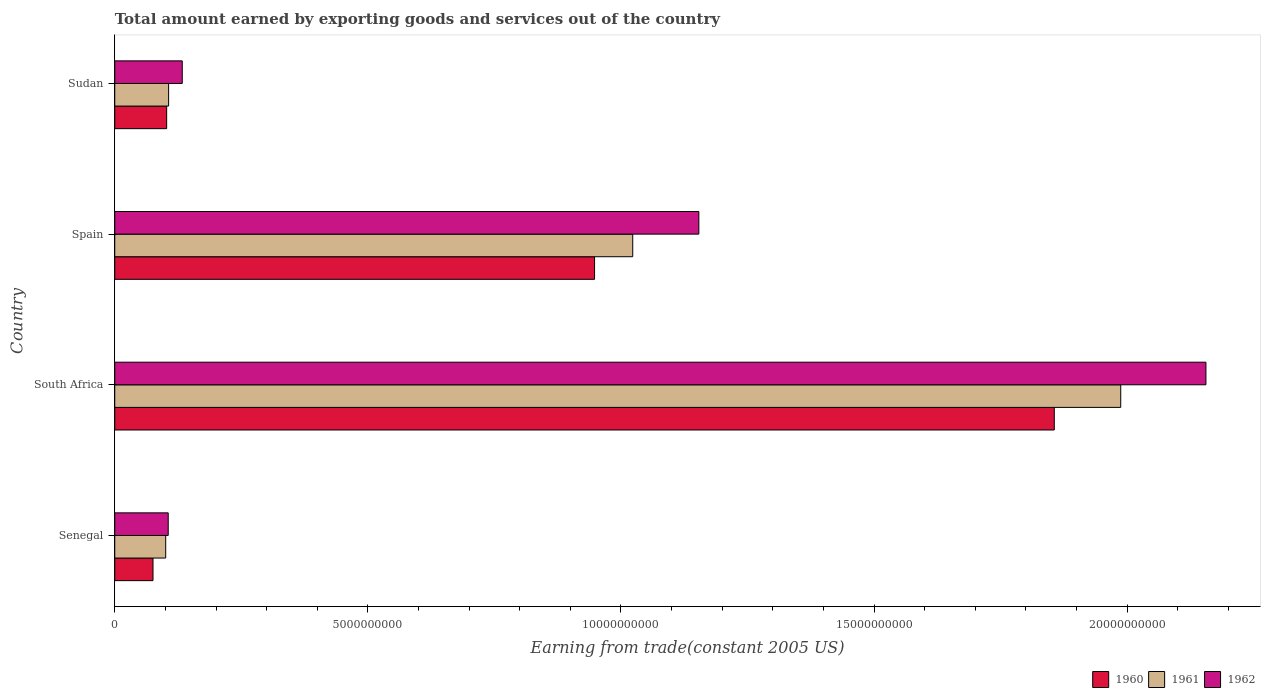How many different coloured bars are there?
Make the answer very short. 3. Are the number of bars on each tick of the Y-axis equal?
Your response must be concise. Yes. What is the label of the 2nd group of bars from the top?
Your answer should be very brief. Spain. In how many cases, is the number of bars for a given country not equal to the number of legend labels?
Offer a terse response. 0. What is the total amount earned by exporting goods and services in 1961 in Spain?
Give a very brief answer. 1.02e+1. Across all countries, what is the maximum total amount earned by exporting goods and services in 1961?
Your response must be concise. 1.99e+1. Across all countries, what is the minimum total amount earned by exporting goods and services in 1961?
Ensure brevity in your answer.  1.01e+09. In which country was the total amount earned by exporting goods and services in 1960 maximum?
Provide a succinct answer. South Africa. In which country was the total amount earned by exporting goods and services in 1961 minimum?
Provide a short and direct response. Senegal. What is the total total amount earned by exporting goods and services in 1960 in the graph?
Your response must be concise. 2.98e+1. What is the difference between the total amount earned by exporting goods and services in 1961 in South Africa and that in Sudan?
Your answer should be compact. 1.88e+1. What is the difference between the total amount earned by exporting goods and services in 1960 in Spain and the total amount earned by exporting goods and services in 1962 in South Africa?
Give a very brief answer. -1.21e+1. What is the average total amount earned by exporting goods and services in 1960 per country?
Provide a short and direct response. 7.45e+09. What is the difference between the total amount earned by exporting goods and services in 1960 and total amount earned by exporting goods and services in 1961 in Sudan?
Your response must be concise. -3.85e+07. In how many countries, is the total amount earned by exporting goods and services in 1960 greater than 14000000000 US$?
Keep it short and to the point. 1. What is the ratio of the total amount earned by exporting goods and services in 1961 in Spain to that in Sudan?
Your answer should be compact. 9.62. Is the total amount earned by exporting goods and services in 1961 in Spain less than that in Sudan?
Provide a succinct answer. No. What is the difference between the highest and the second highest total amount earned by exporting goods and services in 1962?
Provide a succinct answer. 1.00e+1. What is the difference between the highest and the lowest total amount earned by exporting goods and services in 1962?
Ensure brevity in your answer.  2.05e+1. Is the sum of the total amount earned by exporting goods and services in 1961 in South Africa and Spain greater than the maximum total amount earned by exporting goods and services in 1962 across all countries?
Ensure brevity in your answer.  Yes. How many bars are there?
Keep it short and to the point. 12. What is the difference between two consecutive major ticks on the X-axis?
Offer a very short reply. 5.00e+09. Where does the legend appear in the graph?
Your answer should be compact. Bottom right. How are the legend labels stacked?
Give a very brief answer. Horizontal. What is the title of the graph?
Offer a terse response. Total amount earned by exporting goods and services out of the country. What is the label or title of the X-axis?
Make the answer very short. Earning from trade(constant 2005 US). What is the label or title of the Y-axis?
Provide a short and direct response. Country. What is the Earning from trade(constant 2005 US) of 1960 in Senegal?
Offer a very short reply. 7.56e+08. What is the Earning from trade(constant 2005 US) in 1961 in Senegal?
Offer a terse response. 1.01e+09. What is the Earning from trade(constant 2005 US) in 1962 in Senegal?
Make the answer very short. 1.06e+09. What is the Earning from trade(constant 2005 US) in 1960 in South Africa?
Provide a succinct answer. 1.86e+1. What is the Earning from trade(constant 2005 US) of 1961 in South Africa?
Keep it short and to the point. 1.99e+1. What is the Earning from trade(constant 2005 US) of 1962 in South Africa?
Provide a succinct answer. 2.16e+1. What is the Earning from trade(constant 2005 US) in 1960 in Spain?
Offer a very short reply. 9.48e+09. What is the Earning from trade(constant 2005 US) in 1961 in Spain?
Provide a succinct answer. 1.02e+1. What is the Earning from trade(constant 2005 US) in 1962 in Spain?
Ensure brevity in your answer.  1.15e+1. What is the Earning from trade(constant 2005 US) in 1960 in Sudan?
Provide a short and direct response. 1.03e+09. What is the Earning from trade(constant 2005 US) of 1961 in Sudan?
Provide a short and direct response. 1.06e+09. What is the Earning from trade(constant 2005 US) in 1962 in Sudan?
Ensure brevity in your answer.  1.33e+09. Across all countries, what is the maximum Earning from trade(constant 2005 US) of 1960?
Your answer should be very brief. 1.86e+1. Across all countries, what is the maximum Earning from trade(constant 2005 US) in 1961?
Your answer should be compact. 1.99e+1. Across all countries, what is the maximum Earning from trade(constant 2005 US) of 1962?
Give a very brief answer. 2.16e+1. Across all countries, what is the minimum Earning from trade(constant 2005 US) in 1960?
Your answer should be very brief. 7.56e+08. Across all countries, what is the minimum Earning from trade(constant 2005 US) in 1961?
Your response must be concise. 1.01e+09. Across all countries, what is the minimum Earning from trade(constant 2005 US) of 1962?
Provide a short and direct response. 1.06e+09. What is the total Earning from trade(constant 2005 US) in 1960 in the graph?
Offer a very short reply. 2.98e+1. What is the total Earning from trade(constant 2005 US) of 1961 in the graph?
Make the answer very short. 3.22e+1. What is the total Earning from trade(constant 2005 US) of 1962 in the graph?
Your answer should be very brief. 3.55e+1. What is the difference between the Earning from trade(constant 2005 US) of 1960 in Senegal and that in South Africa?
Your answer should be very brief. -1.78e+1. What is the difference between the Earning from trade(constant 2005 US) of 1961 in Senegal and that in South Africa?
Give a very brief answer. -1.89e+1. What is the difference between the Earning from trade(constant 2005 US) in 1962 in Senegal and that in South Africa?
Make the answer very short. -2.05e+1. What is the difference between the Earning from trade(constant 2005 US) in 1960 in Senegal and that in Spain?
Your response must be concise. -8.72e+09. What is the difference between the Earning from trade(constant 2005 US) in 1961 in Senegal and that in Spain?
Your answer should be very brief. -9.23e+09. What is the difference between the Earning from trade(constant 2005 US) in 1962 in Senegal and that in Spain?
Give a very brief answer. -1.05e+1. What is the difference between the Earning from trade(constant 2005 US) of 1960 in Senegal and that in Sudan?
Your response must be concise. -2.70e+08. What is the difference between the Earning from trade(constant 2005 US) of 1961 in Senegal and that in Sudan?
Ensure brevity in your answer.  -5.74e+07. What is the difference between the Earning from trade(constant 2005 US) of 1962 in Senegal and that in Sudan?
Your answer should be compact. -2.77e+08. What is the difference between the Earning from trade(constant 2005 US) in 1960 in South Africa and that in Spain?
Offer a terse response. 9.08e+09. What is the difference between the Earning from trade(constant 2005 US) in 1961 in South Africa and that in Spain?
Make the answer very short. 9.64e+09. What is the difference between the Earning from trade(constant 2005 US) in 1962 in South Africa and that in Spain?
Your answer should be very brief. 1.00e+1. What is the difference between the Earning from trade(constant 2005 US) in 1960 in South Africa and that in Sudan?
Provide a short and direct response. 1.75e+1. What is the difference between the Earning from trade(constant 2005 US) of 1961 in South Africa and that in Sudan?
Your answer should be very brief. 1.88e+1. What is the difference between the Earning from trade(constant 2005 US) of 1962 in South Africa and that in Sudan?
Provide a succinct answer. 2.02e+1. What is the difference between the Earning from trade(constant 2005 US) of 1960 in Spain and that in Sudan?
Give a very brief answer. 8.45e+09. What is the difference between the Earning from trade(constant 2005 US) of 1961 in Spain and that in Sudan?
Ensure brevity in your answer.  9.17e+09. What is the difference between the Earning from trade(constant 2005 US) in 1962 in Spain and that in Sudan?
Offer a very short reply. 1.02e+1. What is the difference between the Earning from trade(constant 2005 US) of 1960 in Senegal and the Earning from trade(constant 2005 US) of 1961 in South Africa?
Give a very brief answer. -1.91e+1. What is the difference between the Earning from trade(constant 2005 US) in 1960 in Senegal and the Earning from trade(constant 2005 US) in 1962 in South Africa?
Give a very brief answer. -2.08e+1. What is the difference between the Earning from trade(constant 2005 US) of 1961 in Senegal and the Earning from trade(constant 2005 US) of 1962 in South Africa?
Keep it short and to the point. -2.05e+1. What is the difference between the Earning from trade(constant 2005 US) in 1960 in Senegal and the Earning from trade(constant 2005 US) in 1961 in Spain?
Your answer should be very brief. -9.48e+09. What is the difference between the Earning from trade(constant 2005 US) of 1960 in Senegal and the Earning from trade(constant 2005 US) of 1962 in Spain?
Keep it short and to the point. -1.08e+1. What is the difference between the Earning from trade(constant 2005 US) of 1961 in Senegal and the Earning from trade(constant 2005 US) of 1962 in Spain?
Your response must be concise. -1.05e+1. What is the difference between the Earning from trade(constant 2005 US) in 1960 in Senegal and the Earning from trade(constant 2005 US) in 1961 in Sudan?
Your answer should be very brief. -3.08e+08. What is the difference between the Earning from trade(constant 2005 US) in 1960 in Senegal and the Earning from trade(constant 2005 US) in 1962 in Sudan?
Provide a succinct answer. -5.78e+08. What is the difference between the Earning from trade(constant 2005 US) of 1961 in Senegal and the Earning from trade(constant 2005 US) of 1962 in Sudan?
Offer a terse response. -3.27e+08. What is the difference between the Earning from trade(constant 2005 US) of 1960 in South Africa and the Earning from trade(constant 2005 US) of 1961 in Spain?
Offer a very short reply. 8.33e+09. What is the difference between the Earning from trade(constant 2005 US) of 1960 in South Africa and the Earning from trade(constant 2005 US) of 1962 in Spain?
Your answer should be very brief. 7.02e+09. What is the difference between the Earning from trade(constant 2005 US) of 1961 in South Africa and the Earning from trade(constant 2005 US) of 1962 in Spain?
Offer a terse response. 8.33e+09. What is the difference between the Earning from trade(constant 2005 US) in 1960 in South Africa and the Earning from trade(constant 2005 US) in 1961 in Sudan?
Keep it short and to the point. 1.75e+1. What is the difference between the Earning from trade(constant 2005 US) in 1960 in South Africa and the Earning from trade(constant 2005 US) in 1962 in Sudan?
Make the answer very short. 1.72e+1. What is the difference between the Earning from trade(constant 2005 US) of 1961 in South Africa and the Earning from trade(constant 2005 US) of 1962 in Sudan?
Give a very brief answer. 1.85e+1. What is the difference between the Earning from trade(constant 2005 US) in 1960 in Spain and the Earning from trade(constant 2005 US) in 1961 in Sudan?
Your response must be concise. 8.41e+09. What is the difference between the Earning from trade(constant 2005 US) of 1960 in Spain and the Earning from trade(constant 2005 US) of 1962 in Sudan?
Your response must be concise. 8.14e+09. What is the difference between the Earning from trade(constant 2005 US) of 1961 in Spain and the Earning from trade(constant 2005 US) of 1962 in Sudan?
Ensure brevity in your answer.  8.90e+09. What is the average Earning from trade(constant 2005 US) in 1960 per country?
Provide a short and direct response. 7.45e+09. What is the average Earning from trade(constant 2005 US) in 1961 per country?
Ensure brevity in your answer.  8.04e+09. What is the average Earning from trade(constant 2005 US) in 1962 per country?
Ensure brevity in your answer.  8.87e+09. What is the difference between the Earning from trade(constant 2005 US) of 1960 and Earning from trade(constant 2005 US) of 1961 in Senegal?
Offer a terse response. -2.51e+08. What is the difference between the Earning from trade(constant 2005 US) in 1960 and Earning from trade(constant 2005 US) in 1962 in Senegal?
Give a very brief answer. -3.00e+08. What is the difference between the Earning from trade(constant 2005 US) in 1961 and Earning from trade(constant 2005 US) in 1962 in Senegal?
Keep it short and to the point. -4.96e+07. What is the difference between the Earning from trade(constant 2005 US) of 1960 and Earning from trade(constant 2005 US) of 1961 in South Africa?
Offer a terse response. -1.31e+09. What is the difference between the Earning from trade(constant 2005 US) in 1960 and Earning from trade(constant 2005 US) in 1962 in South Africa?
Your answer should be compact. -3.00e+09. What is the difference between the Earning from trade(constant 2005 US) of 1961 and Earning from trade(constant 2005 US) of 1962 in South Africa?
Ensure brevity in your answer.  -1.68e+09. What is the difference between the Earning from trade(constant 2005 US) of 1960 and Earning from trade(constant 2005 US) of 1961 in Spain?
Your response must be concise. -7.54e+08. What is the difference between the Earning from trade(constant 2005 US) in 1960 and Earning from trade(constant 2005 US) in 1962 in Spain?
Keep it short and to the point. -2.06e+09. What is the difference between the Earning from trade(constant 2005 US) of 1961 and Earning from trade(constant 2005 US) of 1962 in Spain?
Your answer should be compact. -1.31e+09. What is the difference between the Earning from trade(constant 2005 US) in 1960 and Earning from trade(constant 2005 US) in 1961 in Sudan?
Make the answer very short. -3.85e+07. What is the difference between the Earning from trade(constant 2005 US) in 1960 and Earning from trade(constant 2005 US) in 1962 in Sudan?
Keep it short and to the point. -3.08e+08. What is the difference between the Earning from trade(constant 2005 US) in 1961 and Earning from trade(constant 2005 US) in 1962 in Sudan?
Provide a short and direct response. -2.69e+08. What is the ratio of the Earning from trade(constant 2005 US) in 1960 in Senegal to that in South Africa?
Give a very brief answer. 0.04. What is the ratio of the Earning from trade(constant 2005 US) in 1961 in Senegal to that in South Africa?
Provide a short and direct response. 0.05. What is the ratio of the Earning from trade(constant 2005 US) in 1962 in Senegal to that in South Africa?
Your response must be concise. 0.05. What is the ratio of the Earning from trade(constant 2005 US) of 1960 in Senegal to that in Spain?
Give a very brief answer. 0.08. What is the ratio of the Earning from trade(constant 2005 US) in 1961 in Senegal to that in Spain?
Ensure brevity in your answer.  0.1. What is the ratio of the Earning from trade(constant 2005 US) of 1962 in Senegal to that in Spain?
Keep it short and to the point. 0.09. What is the ratio of the Earning from trade(constant 2005 US) of 1960 in Senegal to that in Sudan?
Ensure brevity in your answer.  0.74. What is the ratio of the Earning from trade(constant 2005 US) of 1961 in Senegal to that in Sudan?
Keep it short and to the point. 0.95. What is the ratio of the Earning from trade(constant 2005 US) in 1962 in Senegal to that in Sudan?
Make the answer very short. 0.79. What is the ratio of the Earning from trade(constant 2005 US) of 1960 in South Africa to that in Spain?
Make the answer very short. 1.96. What is the ratio of the Earning from trade(constant 2005 US) of 1961 in South Africa to that in Spain?
Provide a short and direct response. 1.94. What is the ratio of the Earning from trade(constant 2005 US) of 1962 in South Africa to that in Spain?
Make the answer very short. 1.87. What is the ratio of the Earning from trade(constant 2005 US) of 1960 in South Africa to that in Sudan?
Keep it short and to the point. 18.1. What is the ratio of the Earning from trade(constant 2005 US) of 1961 in South Africa to that in Sudan?
Your answer should be compact. 18.68. What is the ratio of the Earning from trade(constant 2005 US) in 1962 in South Africa to that in Sudan?
Keep it short and to the point. 16.17. What is the ratio of the Earning from trade(constant 2005 US) in 1960 in Spain to that in Sudan?
Keep it short and to the point. 9.24. What is the ratio of the Earning from trade(constant 2005 US) in 1961 in Spain to that in Sudan?
Offer a very short reply. 9.62. What is the ratio of the Earning from trade(constant 2005 US) of 1962 in Spain to that in Sudan?
Your answer should be very brief. 8.65. What is the difference between the highest and the second highest Earning from trade(constant 2005 US) in 1960?
Your answer should be very brief. 9.08e+09. What is the difference between the highest and the second highest Earning from trade(constant 2005 US) of 1961?
Ensure brevity in your answer.  9.64e+09. What is the difference between the highest and the second highest Earning from trade(constant 2005 US) of 1962?
Your response must be concise. 1.00e+1. What is the difference between the highest and the lowest Earning from trade(constant 2005 US) of 1960?
Your answer should be very brief. 1.78e+1. What is the difference between the highest and the lowest Earning from trade(constant 2005 US) in 1961?
Keep it short and to the point. 1.89e+1. What is the difference between the highest and the lowest Earning from trade(constant 2005 US) of 1962?
Your response must be concise. 2.05e+1. 